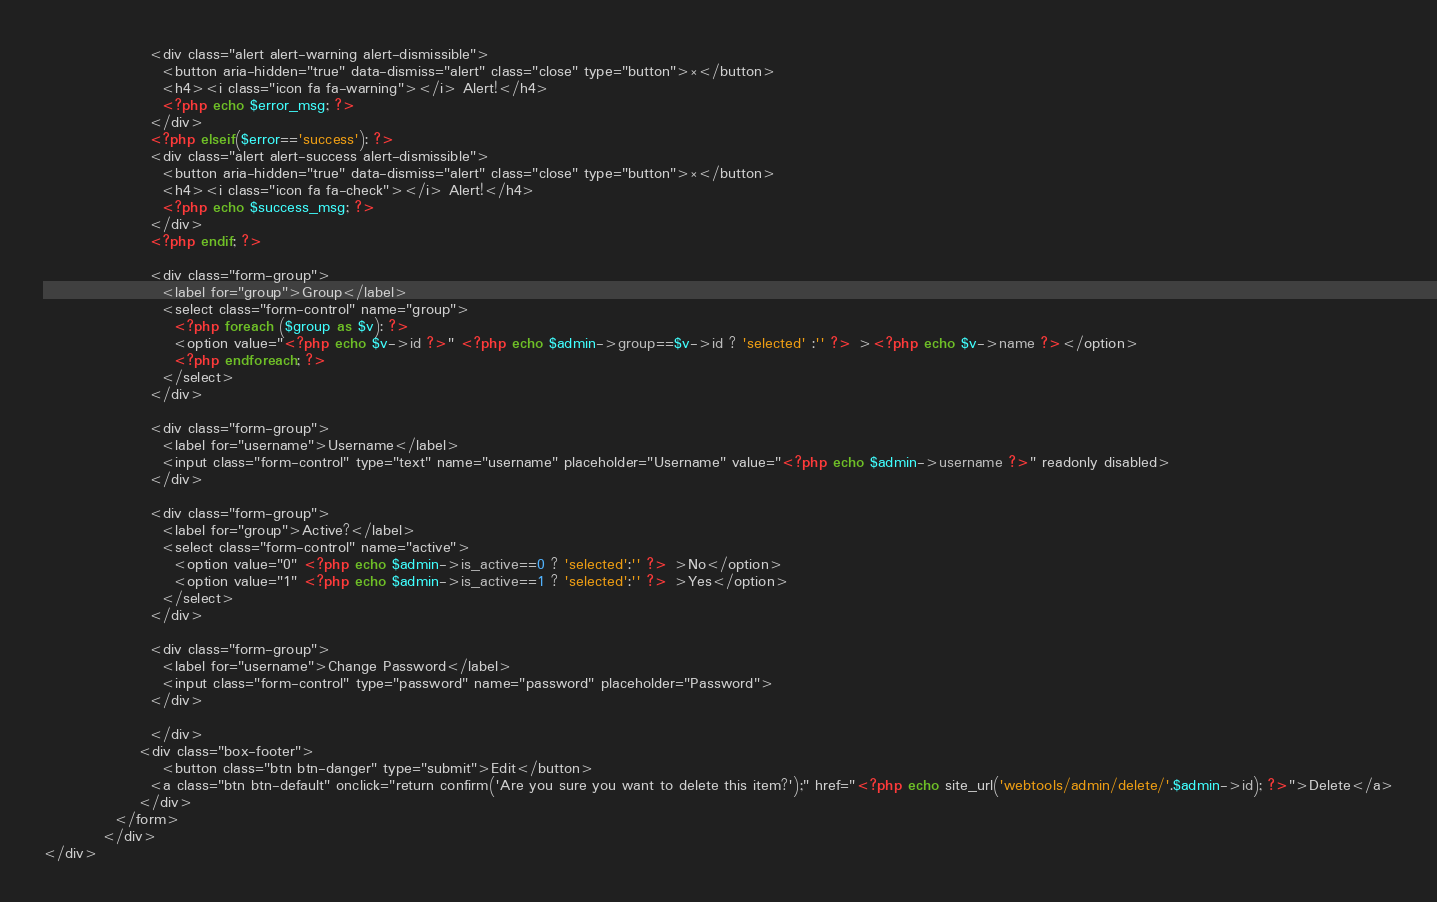Convert code to text. <code><loc_0><loc_0><loc_500><loc_500><_PHP_>                  <div class="alert alert-warning alert-dismissible">
                    <button aria-hidden="true" data-dismiss="alert" class="close" type="button">×</button>
                    <h4><i class="icon fa fa-warning"></i> Alert!</h4>
                    <?php echo $error_msg; ?>
                  </div>
                  <?php elseif($error=='success'): ?>
                  <div class="alert alert-success alert-dismissible">
                    <button aria-hidden="true" data-dismiss="alert" class="close" type="button">×</button>
                    <h4><i class="icon fa fa-check"></i> Alert!</h4>
                    <?php echo $success_msg; ?>
                  </div>
                  <?php endif; ?>

                  <div class="form-group">
                    <label for="group">Group</label>
                    <select class="form-control" name="group">
                      <?php foreach ($group as $v): ?>
                      <option value="<?php echo $v->id ?>" <?php echo $admin->group==$v->id ? 'selected' :'' ?> ><?php echo $v->name ?></option>
                      <?php endforeach; ?>
                    </select>
                  </div>

                  <div class="form-group">
                    <label for="username">Username</label>
                    <input class="form-control" type="text" name="username" placeholder="Username" value="<?php echo $admin->username ?>" readonly disabled>
                  </div>

                  <div class="form-group">
                    <label for="group">Active?</label>
                    <select class="form-control" name="active">
                      <option value="0" <?php echo $admin->is_active==0 ? 'selected':'' ?> >No</option>
                      <option value="1" <?php echo $admin->is_active==1 ? 'selected':'' ?> >Yes</option>
                    </select>
                  </div>

                  <div class="form-group">
                    <label for="username">Change Password</label>
                    <input class="form-control" type="password" name="password" placeholder="Password">
                  </div>

	              </div>
              	<div class="box-footer">
                	<button class="btn btn-danger" type="submit">Edit</button>
                  <a class="btn btn-default" onclick="return confirm('Are you sure you want to delete this item?');" href="<?php echo site_url('webtools/admin/delete/'.$admin->id); ?>">Delete</a>
              	</div>
            </form>
          </div>
</div></code> 